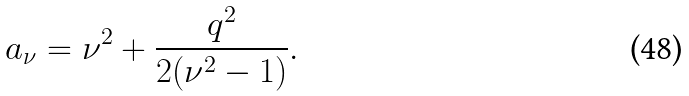<formula> <loc_0><loc_0><loc_500><loc_500>a _ { \nu } = \nu ^ { 2 } + \frac { q ^ { 2 } } { 2 ( \nu ^ { 2 } - 1 ) } .</formula> 